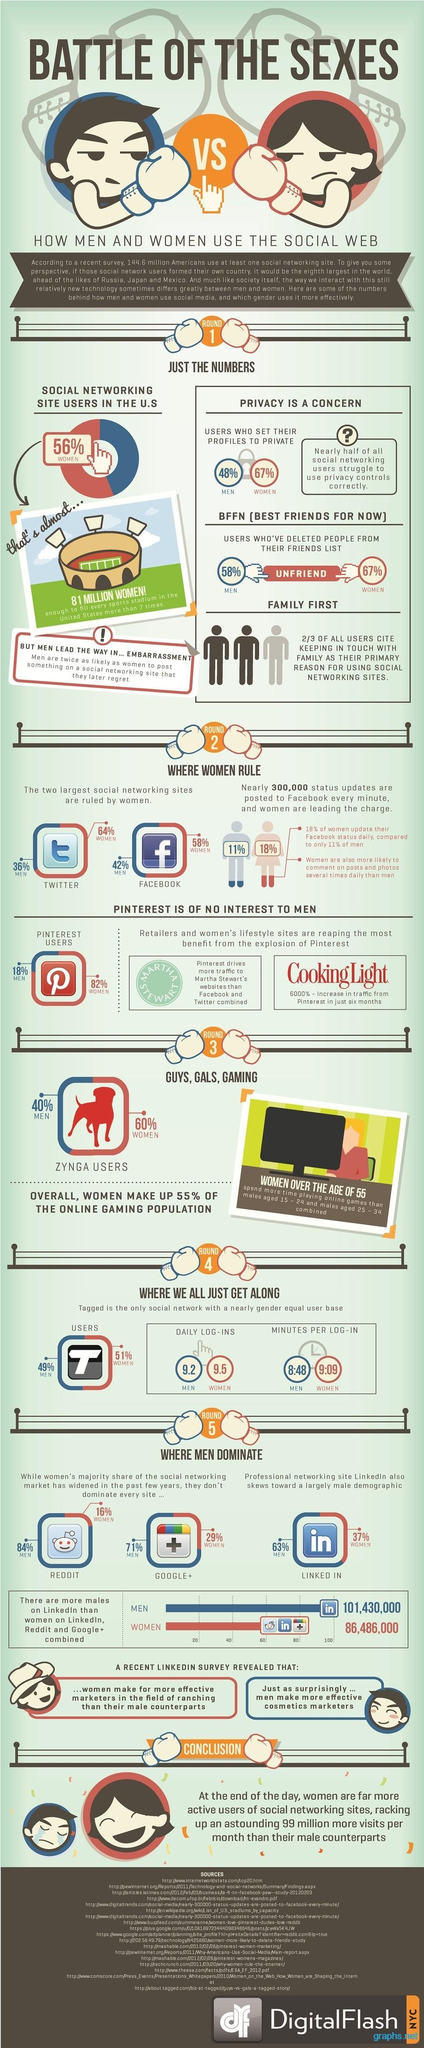Give some essential details in this illustration. According to a survey, 36% of Twitter users in America are men. According to a survey, 58% of Facebook users in America are women. According to data, approximately 60% of Zynga users in America are women. According to the survey, female "tagged" users in America spend approximately 9 minutes and 9 seconds per log-in on average. According to a survey, 101,430,000 men in America are LinkedIn users. 